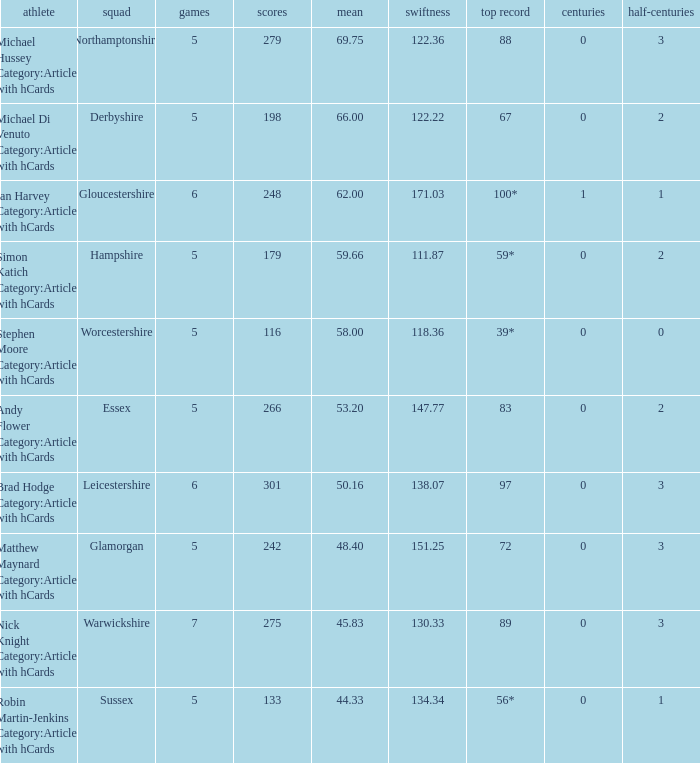In a series of 5 matches, what was the top score for the worcestershire team? 39*. 